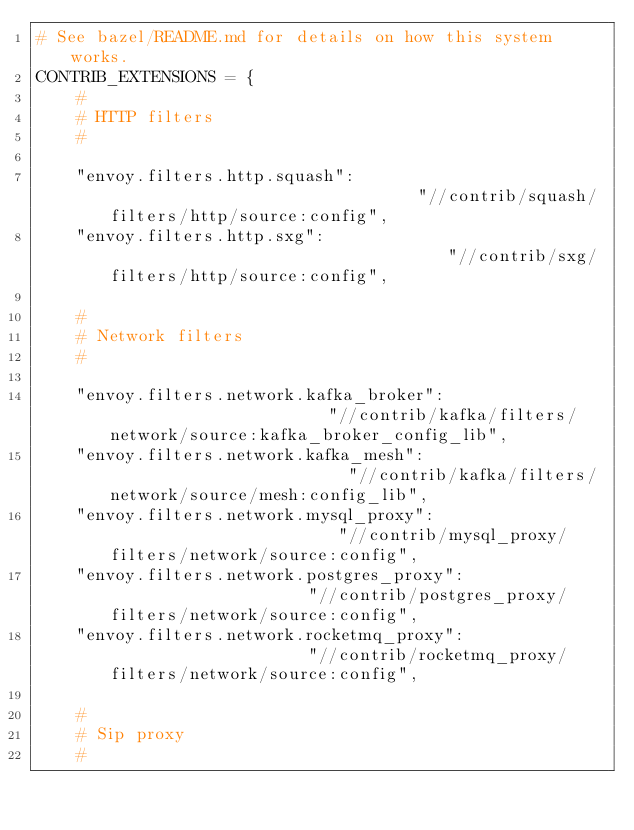<code> <loc_0><loc_0><loc_500><loc_500><_Python_># See bazel/README.md for details on how this system works.
CONTRIB_EXTENSIONS = {
    #
    # HTTP filters
    #

    "envoy.filters.http.squash":                                "//contrib/squash/filters/http/source:config",
    "envoy.filters.http.sxg":                                   "//contrib/sxg/filters/http/source:config",

    #
    # Network filters
    #

    "envoy.filters.network.kafka_broker":                       "//contrib/kafka/filters/network/source:kafka_broker_config_lib",
    "envoy.filters.network.kafka_mesh":                         "//contrib/kafka/filters/network/source/mesh:config_lib",
    "envoy.filters.network.mysql_proxy":                        "//contrib/mysql_proxy/filters/network/source:config",
    "envoy.filters.network.postgres_proxy":                     "//contrib/postgres_proxy/filters/network/source:config",
    "envoy.filters.network.rocketmq_proxy":                     "//contrib/rocketmq_proxy/filters/network/source:config",

    #
    # Sip proxy
    #
</code> 